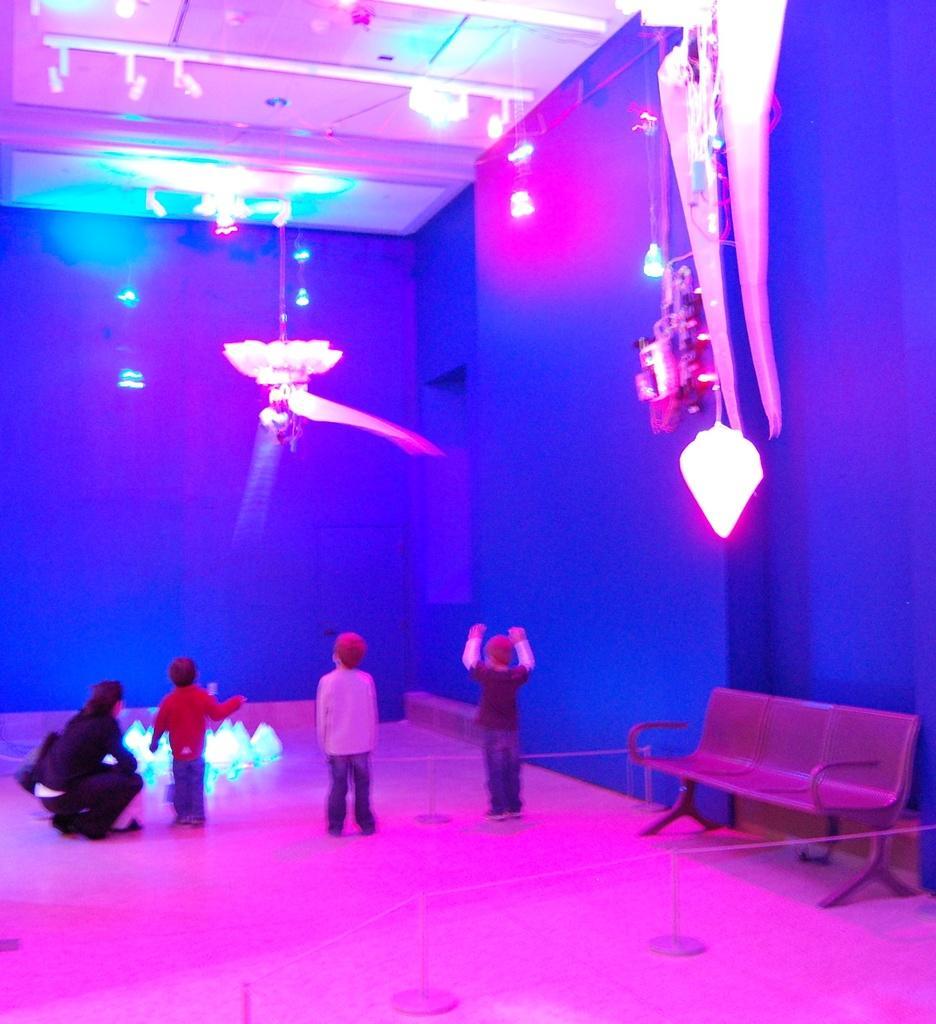Can you describe this image briefly? In this image there are three kids and a woman, she is sitting on floor, beside the kid there is a bench at the top there are a lights. 